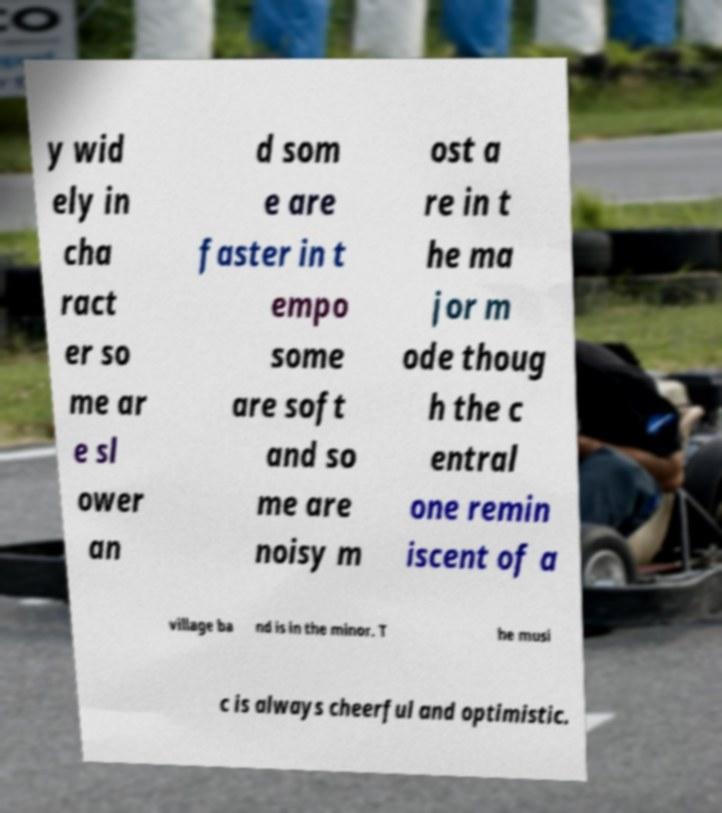Please read and relay the text visible in this image. What does it say? y wid ely in cha ract er so me ar e sl ower an d som e are faster in t empo some are soft and so me are noisy m ost a re in t he ma jor m ode thoug h the c entral one remin iscent of a village ba nd is in the minor. T he musi c is always cheerful and optimistic. 